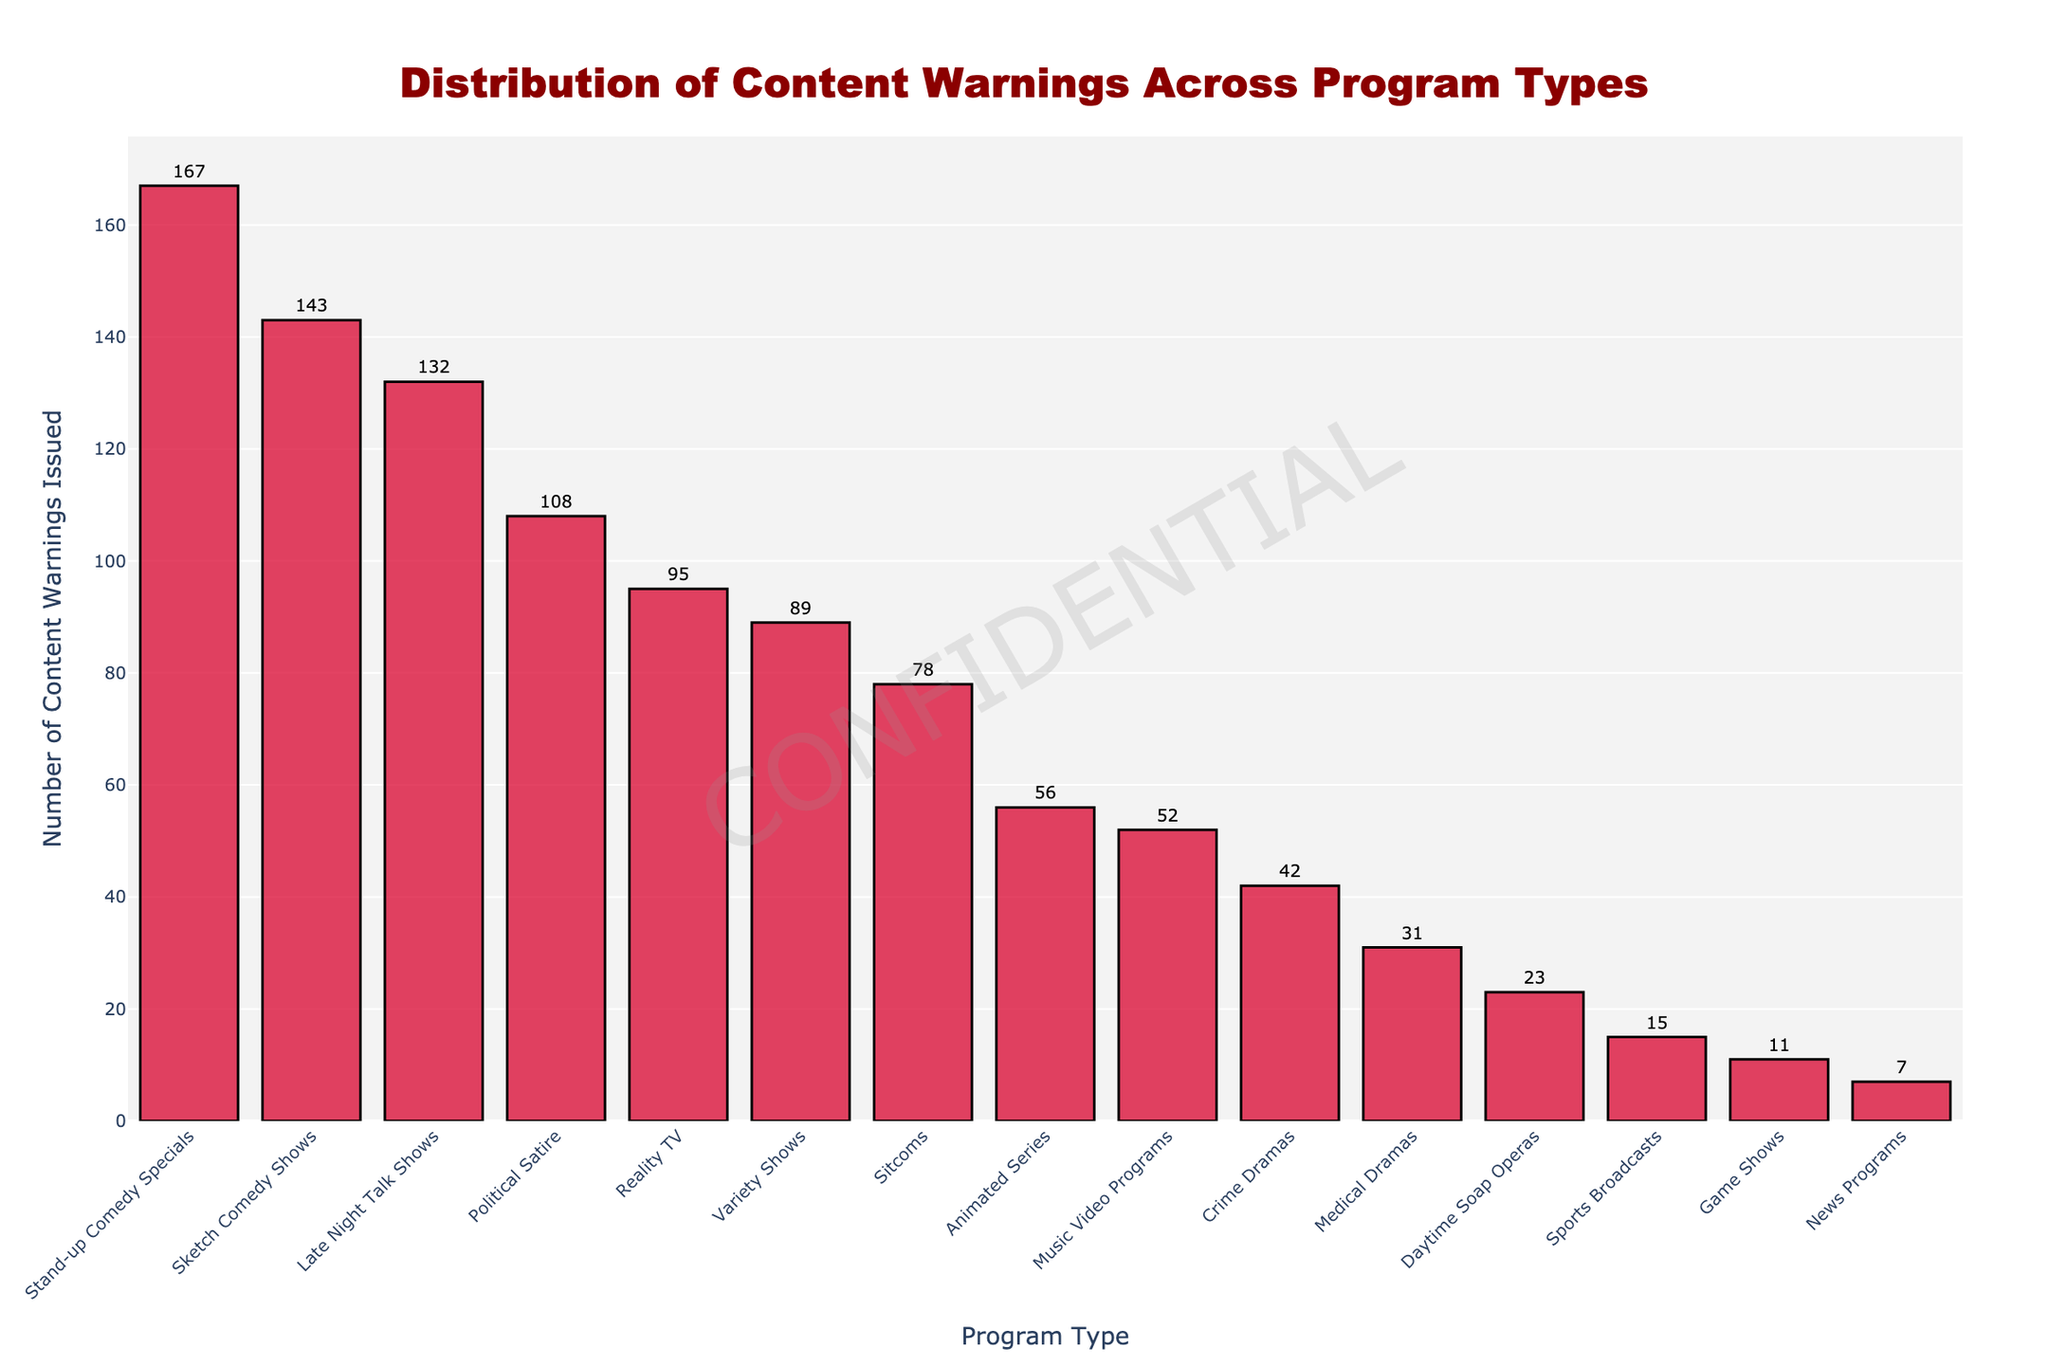Which program type received the highest number of content warnings? Locate the tallest bar in the chart, which corresponds to "Stand-up Comedy Specials" with a height of 167.
Answer: Stand-up Comedy Specials Which program type received the fewest content warnings? Locate the shortest bar, which corresponds to "News Programs" with a height of 7.
Answer: News Programs What is the difference in content warnings issued between Sketch Comedy Shows and Sports Broadcasts? Identify the heights of the bars for Sketch Comedy Shows (143) and Sports Broadcasts (15). Perform the subtraction: 143 - 15.
Answer: 128 How many more warnings were issued for Late Night Talk Shows compared to Crime Dramas? Identify the heights of the bars for Late Night Talk Shows (132) and Crime Dramas (42). Perform the subtraction: 132 - 42.
Answer: 90 What is the total number of content warnings issued for Sitcoms, Reality TV, and Animated Series combined? Identify the heights of the bars for Sitcoms (78), Reality TV (95), and Animated Series (56). Perform the addition: 78 + 95 + 56.
Answer: 229 Which program type ranks third highest in terms of content warnings issued? Sort the heights of the bars in descending order and find the third highest, which corresponds to "Sketch Comedy Shows" with a height of 143.
Answer: Sketch Comedy Shows Are there more content warnings for Political Satire shows or Medical Dramas? Compare the heights of the bars for Political Satire (108) and Medical Dramas (31). Political Satire has more warnings.
Answer: Political Satire What is the average number of content warnings issued for the top five program types? Identify the heights of the bars for the top five program types: Stand-up Comedy Specials (167), Sketch Comedy Shows (143), Late Night Talk Shows (132), Political Satire (108), and Reality TV (95). Perform the addition: 167 + 143 + 132 + 108 + 95 = 645. Calculate the average: 645 / 5.
Answer: 129 How does the number of content warnings issued for Variety Shows compare to Music Video Programs? Compare the heights of the bars for Variety Shows (89) and Music Video Programs (52). Variety Shows have more warnings.
Answer: Variety Shows What percentage of total content warnings were issued for Sketch Comedy Shows? Sum the heights of the bars for all program types to find the total, then find the height for Sketch Comedy Shows (143). Divide 143 by the total and multiply by 100. (143 / 1050) * 100 ≈ 13.62%.
Answer: 13.62% 